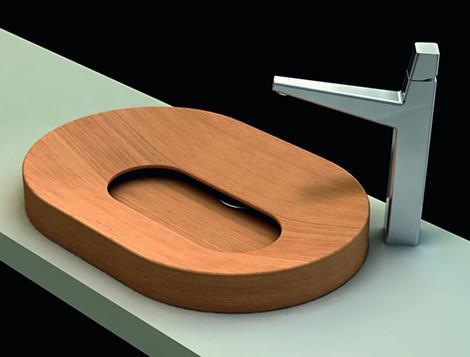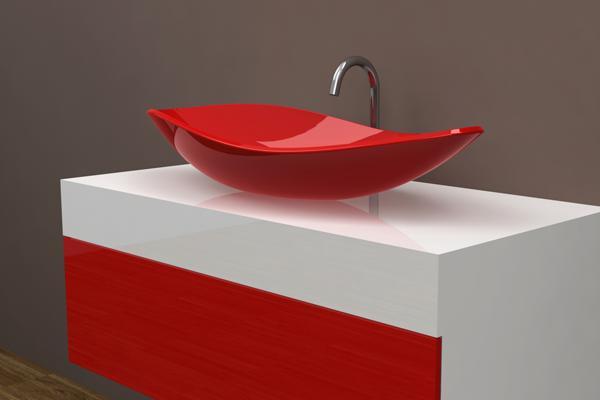The first image is the image on the left, the second image is the image on the right. For the images displayed, is the sentence "The sink on the left is a circular shape with a white interior" factually correct? Answer yes or no. No. 